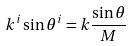<formula> <loc_0><loc_0><loc_500><loc_500>k ^ { i } \sin \theta ^ { i } = k \frac { \sin \theta } { M }</formula> 